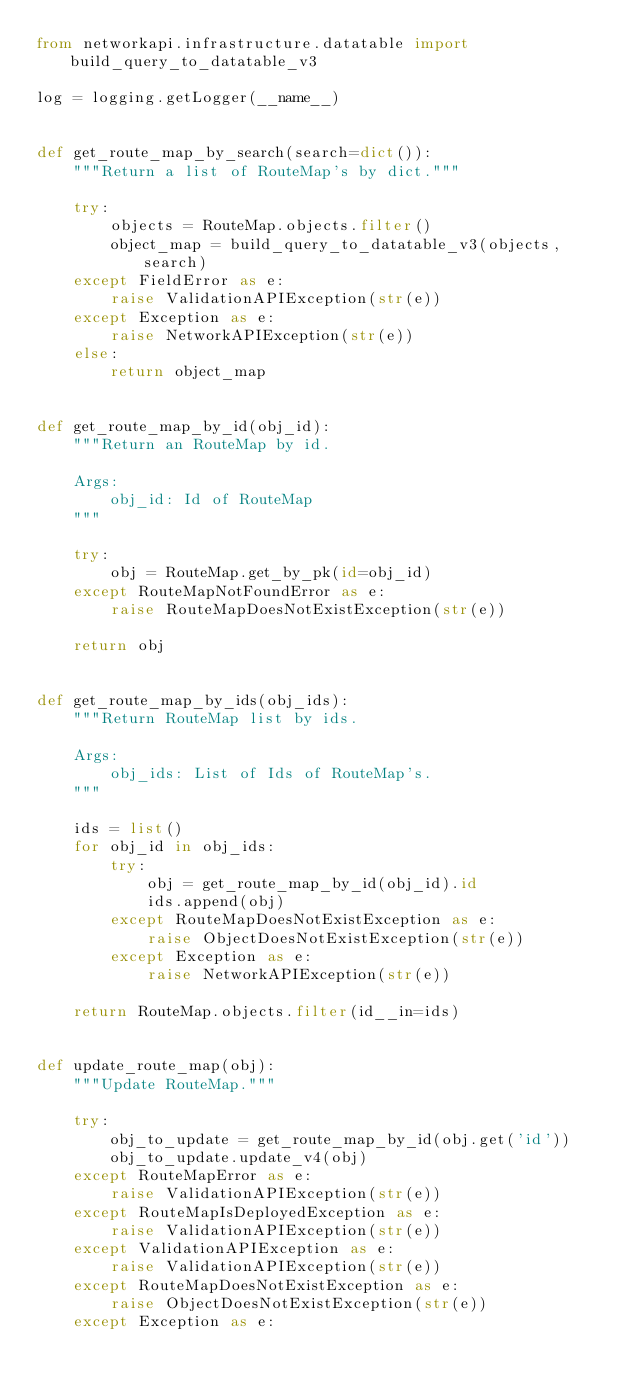Convert code to text. <code><loc_0><loc_0><loc_500><loc_500><_Python_>from networkapi.infrastructure.datatable import build_query_to_datatable_v3

log = logging.getLogger(__name__)


def get_route_map_by_search(search=dict()):
    """Return a list of RouteMap's by dict."""

    try:
        objects = RouteMap.objects.filter()
        object_map = build_query_to_datatable_v3(objects, search)
    except FieldError as e:
        raise ValidationAPIException(str(e))
    except Exception as e:
        raise NetworkAPIException(str(e))
    else:
        return object_map


def get_route_map_by_id(obj_id):
    """Return an RouteMap by id.

    Args:
        obj_id: Id of RouteMap
    """

    try:
        obj = RouteMap.get_by_pk(id=obj_id)
    except RouteMapNotFoundError as e:
        raise RouteMapDoesNotExistException(str(e))

    return obj


def get_route_map_by_ids(obj_ids):
    """Return RouteMap list by ids.

    Args:
        obj_ids: List of Ids of RouteMap's.
    """

    ids = list()
    for obj_id in obj_ids:
        try:
            obj = get_route_map_by_id(obj_id).id
            ids.append(obj)
        except RouteMapDoesNotExistException as e:
            raise ObjectDoesNotExistException(str(e))
        except Exception as e:
            raise NetworkAPIException(str(e))

    return RouteMap.objects.filter(id__in=ids)


def update_route_map(obj):
    """Update RouteMap."""

    try:
        obj_to_update = get_route_map_by_id(obj.get('id'))
        obj_to_update.update_v4(obj)
    except RouteMapError as e:
        raise ValidationAPIException(str(e))
    except RouteMapIsDeployedException as e:
        raise ValidationAPIException(str(e))
    except ValidationAPIException as e:
        raise ValidationAPIException(str(e))
    except RouteMapDoesNotExistException as e:
        raise ObjectDoesNotExistException(str(e))
    except Exception as e:</code> 